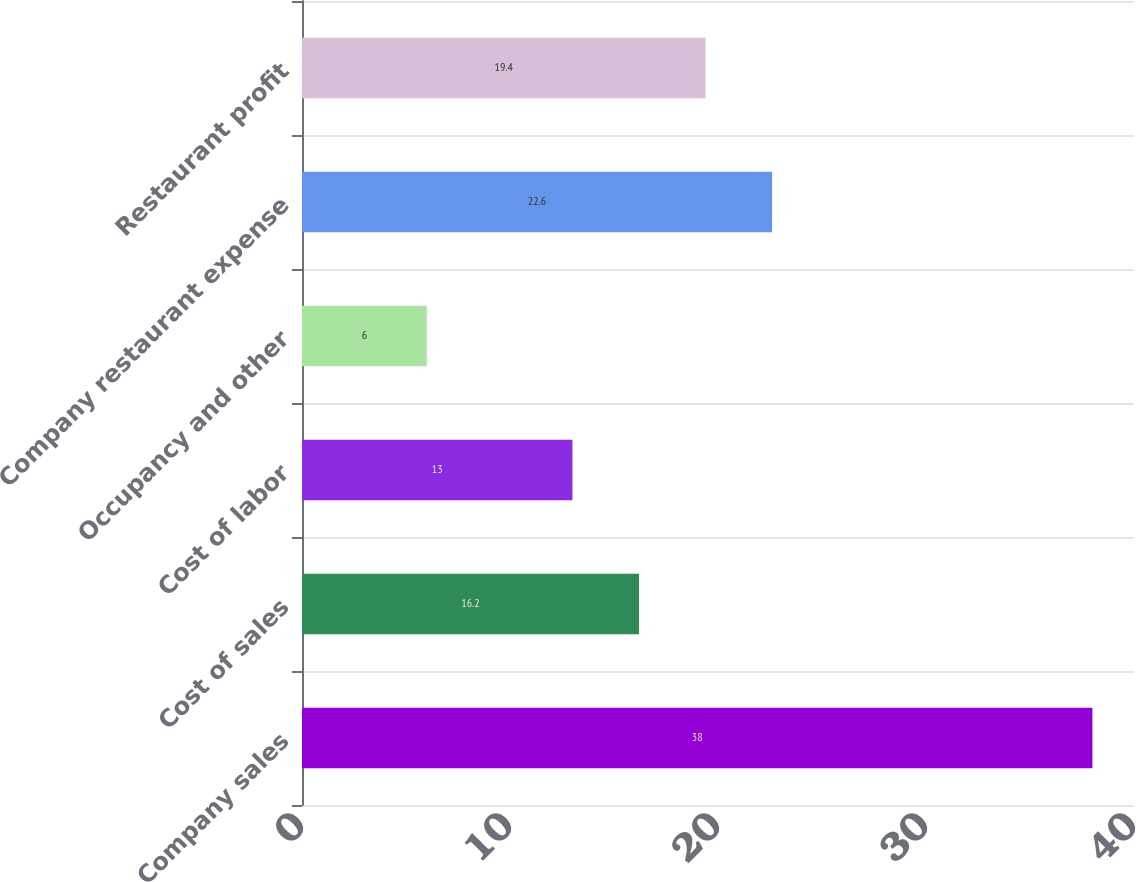Convert chart to OTSL. <chart><loc_0><loc_0><loc_500><loc_500><bar_chart><fcel>Company sales<fcel>Cost of sales<fcel>Cost of labor<fcel>Occupancy and other<fcel>Company restaurant expense<fcel>Restaurant profit<nl><fcel>38<fcel>16.2<fcel>13<fcel>6<fcel>22.6<fcel>19.4<nl></chart> 